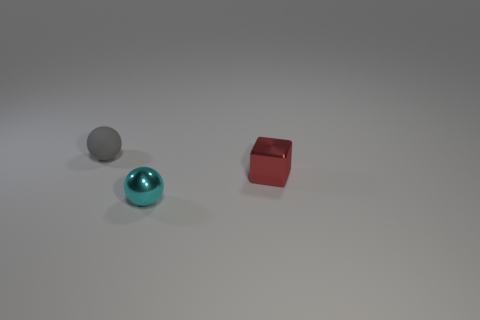What number of tiny things are both to the left of the red object and right of the tiny gray matte ball?
Offer a terse response. 1. There is a small shiny thing to the left of the red object; what shape is it?
Give a very brief answer. Sphere. How many blue matte balls have the same size as the shiny cube?
Your response must be concise. 0. Do the shiny object in front of the cube and the metal block have the same color?
Your response must be concise. No. There is a tiny thing that is to the right of the matte thing and left of the red thing; what is its material?
Keep it short and to the point. Metal. Are there more small red metallic things than large shiny things?
Give a very brief answer. Yes. There is a metal thing that is behind the small ball that is right of the small sphere on the left side of the cyan metallic sphere; what is its color?
Give a very brief answer. Red. Is the material of the sphere behind the tiny cyan sphere the same as the small cyan object?
Your answer should be compact. No. Are any small green metal cubes visible?
Ensure brevity in your answer.  No. Do the ball that is behind the cyan object and the cyan metal thing have the same size?
Make the answer very short. Yes. 